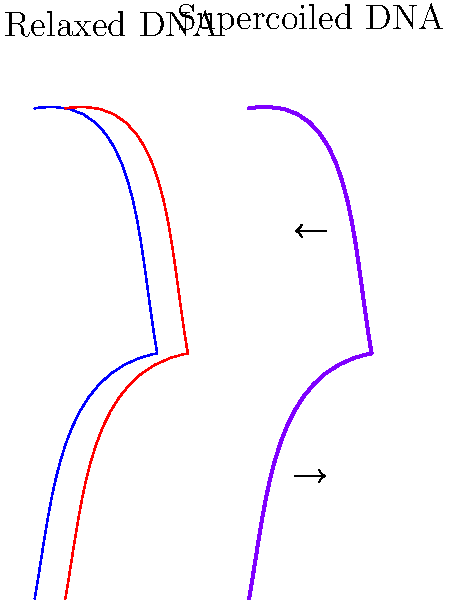How does DNA supercoiling, as shown in the diagram, affect gene expression in prokaryotes? Explain the mechanism and its significance in terms of transcriptional regulation. 1. DNA supercoiling: The diagram shows both relaxed and supercoiled DNA. Supercoiling introduces torsional stress in the DNA molecule.

2. Effect on DNA structure: Supercoiling alters the local structure of DNA, affecting the ease with which the double helix can be separated.

3. Impact on transcription initiation:
   a) Negative supercoiling (underwinding) generally facilitates transcription initiation by making it easier to separate DNA strands.
   b) Positive supercoiling (overwinding) typically inhibits transcription initiation by making strand separation more difficult.

4. Regulation of gene expression:
   a) Prokaryotes maintain their chromosomes in a negatively supercoiled state, which generally promotes gene expression.
   b) Local changes in supercoiling can act as a regulatory mechanism for specific genes.

5. Topoisomerases: These enzymes modulate DNA supercoiling, indirectly affecting gene expression.

6. Energy storage: Supercoiling stores energy in the DNA molecule, which can be used to drive processes like transcription initiation.

7. Global gene regulation: Changes in overall supercoiling levels can affect the expression of many genes simultaneously, allowing bacteria to respond to environmental changes.

8. Significance in prokaryotes: Due to the lack of histones and nucleosomes in prokaryotes, supercoiling plays a crucial role in DNA compaction and gene regulation.
Answer: DNA supercoiling facilitates transcription initiation in prokaryotes by altering DNA structure, with negative supercoiling generally promoting and positive supercoiling inhibiting gene expression, serving as a global regulatory mechanism. 